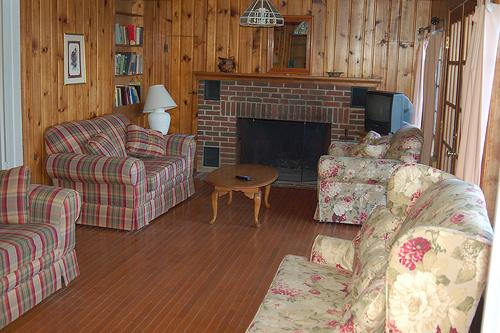What kind of floor is visible and what color is it in the image? A dark colored hard wood floor is visible in the image. Briefly describe the fireplace and its surroundings in the image. A red brick fireplace is against the wall, with wooden paneling on the walls and a light hanging from the ceiling. Identify the table and the items placed on it in the image. A light, wooden coffee table is present with a remote control on it. Point out the type and location of the bookshelf in the image. The bookshelf is recessed, wooden, and located on the wall. What kind of lamp is present and where is it placed in the image? A white lamp with a white shade is placed on the side table. Give a brief description of the television in the image. A black television can be seen in the corner of the room in the image. Mention the seating options in the image and their patterns. There is a red and grey plaid couch and a pink and white floral armchair as seating options in the image. What item is on the table and describe its color. A remote control is on the table, which is black in color. List the distinct elements hanging on the wall in the image. A framed picture, a painting, and many books on three shelves are hanging on the wall. Describe the color and design of the sofa chair in the image. The sofa chair has a pink and white color with a floral design. 